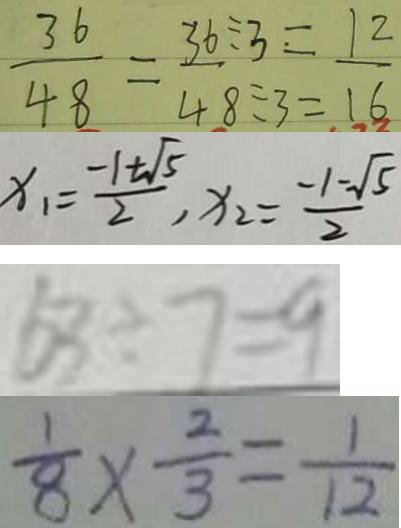Convert formula to latex. <formula><loc_0><loc_0><loc_500><loc_500>\frac { 3 6 } { 4 8 } = \frac { 3 6 } { 4 8 } ^ { \div 3 = } _ { \div 3 = } \frac { 1 2 } { 1 6 } 
 x _ { 1 } = \frac { - 1 + \sqrt { 5 } } { 2 } , x _ { 2 } = \frac { - 1 - \sqrt { 5 } } { 2 } 
 5 3 \div 7 = 9 
 \frac { 1 } { 8 } \times \frac { 2 } { 3 } = \frac { 1 } { 1 2 }</formula> 